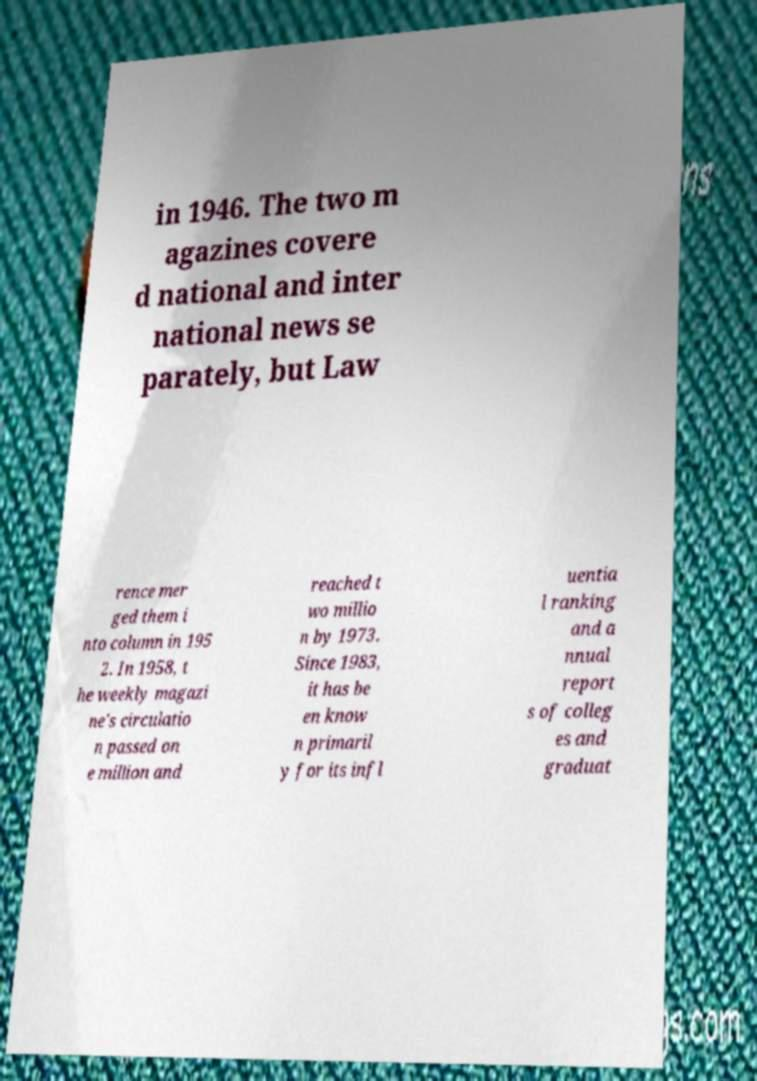Could you extract and type out the text from this image? in 1946. The two m agazines covere d national and inter national news se parately, but Law rence mer ged them i nto column in 195 2. In 1958, t he weekly magazi ne's circulatio n passed on e million and reached t wo millio n by 1973. Since 1983, it has be en know n primaril y for its infl uentia l ranking and a nnual report s of colleg es and graduat 